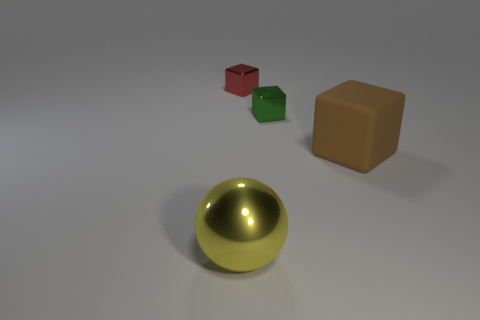Add 4 brown shiny cubes. How many objects exist? 8 Subtract all balls. How many objects are left? 3 Subtract all tiny red metallic things. Subtract all small green rubber objects. How many objects are left? 3 Add 2 green metal objects. How many green metal objects are left? 3 Add 3 shiny blocks. How many shiny blocks exist? 5 Subtract 0 gray cylinders. How many objects are left? 4 